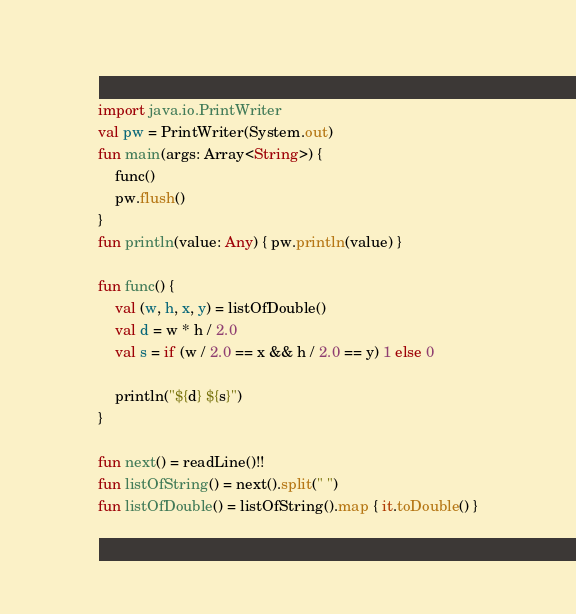<code> <loc_0><loc_0><loc_500><loc_500><_Kotlin_>import java.io.PrintWriter
val pw = PrintWriter(System.out)
fun main(args: Array<String>) {
    func()
    pw.flush()
}
fun println(value: Any) { pw.println(value) }

fun func() {
    val (w, h, x, y) = listOfDouble()
    val d = w * h / 2.0
    val s = if (w / 2.0 == x && h / 2.0 == y) 1 else 0

    println("${d} ${s}")
}

fun next() = readLine()!!
fun listOfString() = next().split(" ")
fun listOfDouble() = listOfString().map { it.toDouble() }
</code> 